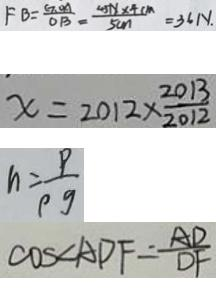<formula> <loc_0><loc_0><loc_500><loc_500>F B = \frac { G O A } { O B } = \frac { 4 5 N \times 4 c m } { 5 c m } = 3 6 N . 
 x = 2 0 1 2 \times \frac { 2 0 1 3 } { 2 0 1 2 } 
 n = \frac { P } { p g } 
 \cos \angle A D F = \frac { A D } { D F }</formula> 